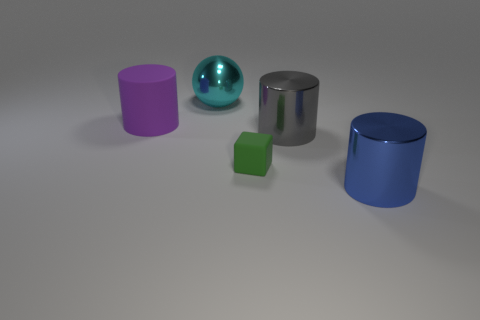How many other objects are the same shape as the green thing?
Provide a short and direct response. 0. There is a cylinder on the left side of the gray thing right of the cylinder on the left side of the big gray shiny thing; what size is it?
Offer a very short reply. Large. What number of brown things are large balls or rubber things?
Offer a terse response. 0. What is the shape of the large metal thing that is behind the cylinder left of the big sphere?
Offer a terse response. Sphere. There is a rubber thing on the left side of the large sphere; is its size the same as the rubber object that is on the right side of the sphere?
Provide a short and direct response. No. Is there a large ball made of the same material as the large gray thing?
Make the answer very short. Yes. There is a matte object to the right of the shiny ball on the left side of the big gray object; are there any blue shiny cylinders that are to the right of it?
Keep it short and to the point. Yes. Are there any purple cylinders on the left side of the green matte thing?
Ensure brevity in your answer.  Yes. There is a object in front of the tiny green rubber thing; how many large cyan spheres are in front of it?
Provide a succinct answer. 0. Does the block have the same size as the metal object that is on the left side of the tiny thing?
Keep it short and to the point. No. 